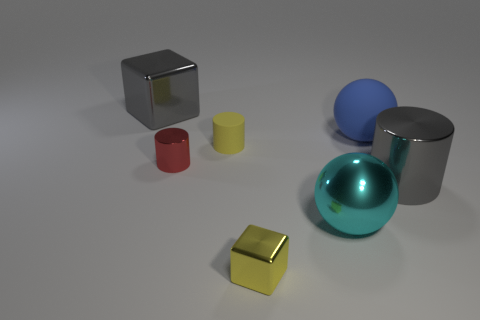What does the arrangement of these objects tell us? Is there any pattern? The objects seem to be arranged in a way that isn't immediately indicative of a specific pattern. They appear to be intentionally placed with consideration for balance and space, but without a clear mathematical or symmetrical pattern.  How does the lighting affect the appearance of the objects? The lighting plays an essential role in defining the objects' textures and colors. It highlights the reflective properties of the spheres, the matte finish of the cylinder, and gives the cube a polished appearance. Shadows and subtle reflections on the ground suggest an ambient light source, contributing to the overall three-dimensional feel of the scene. 